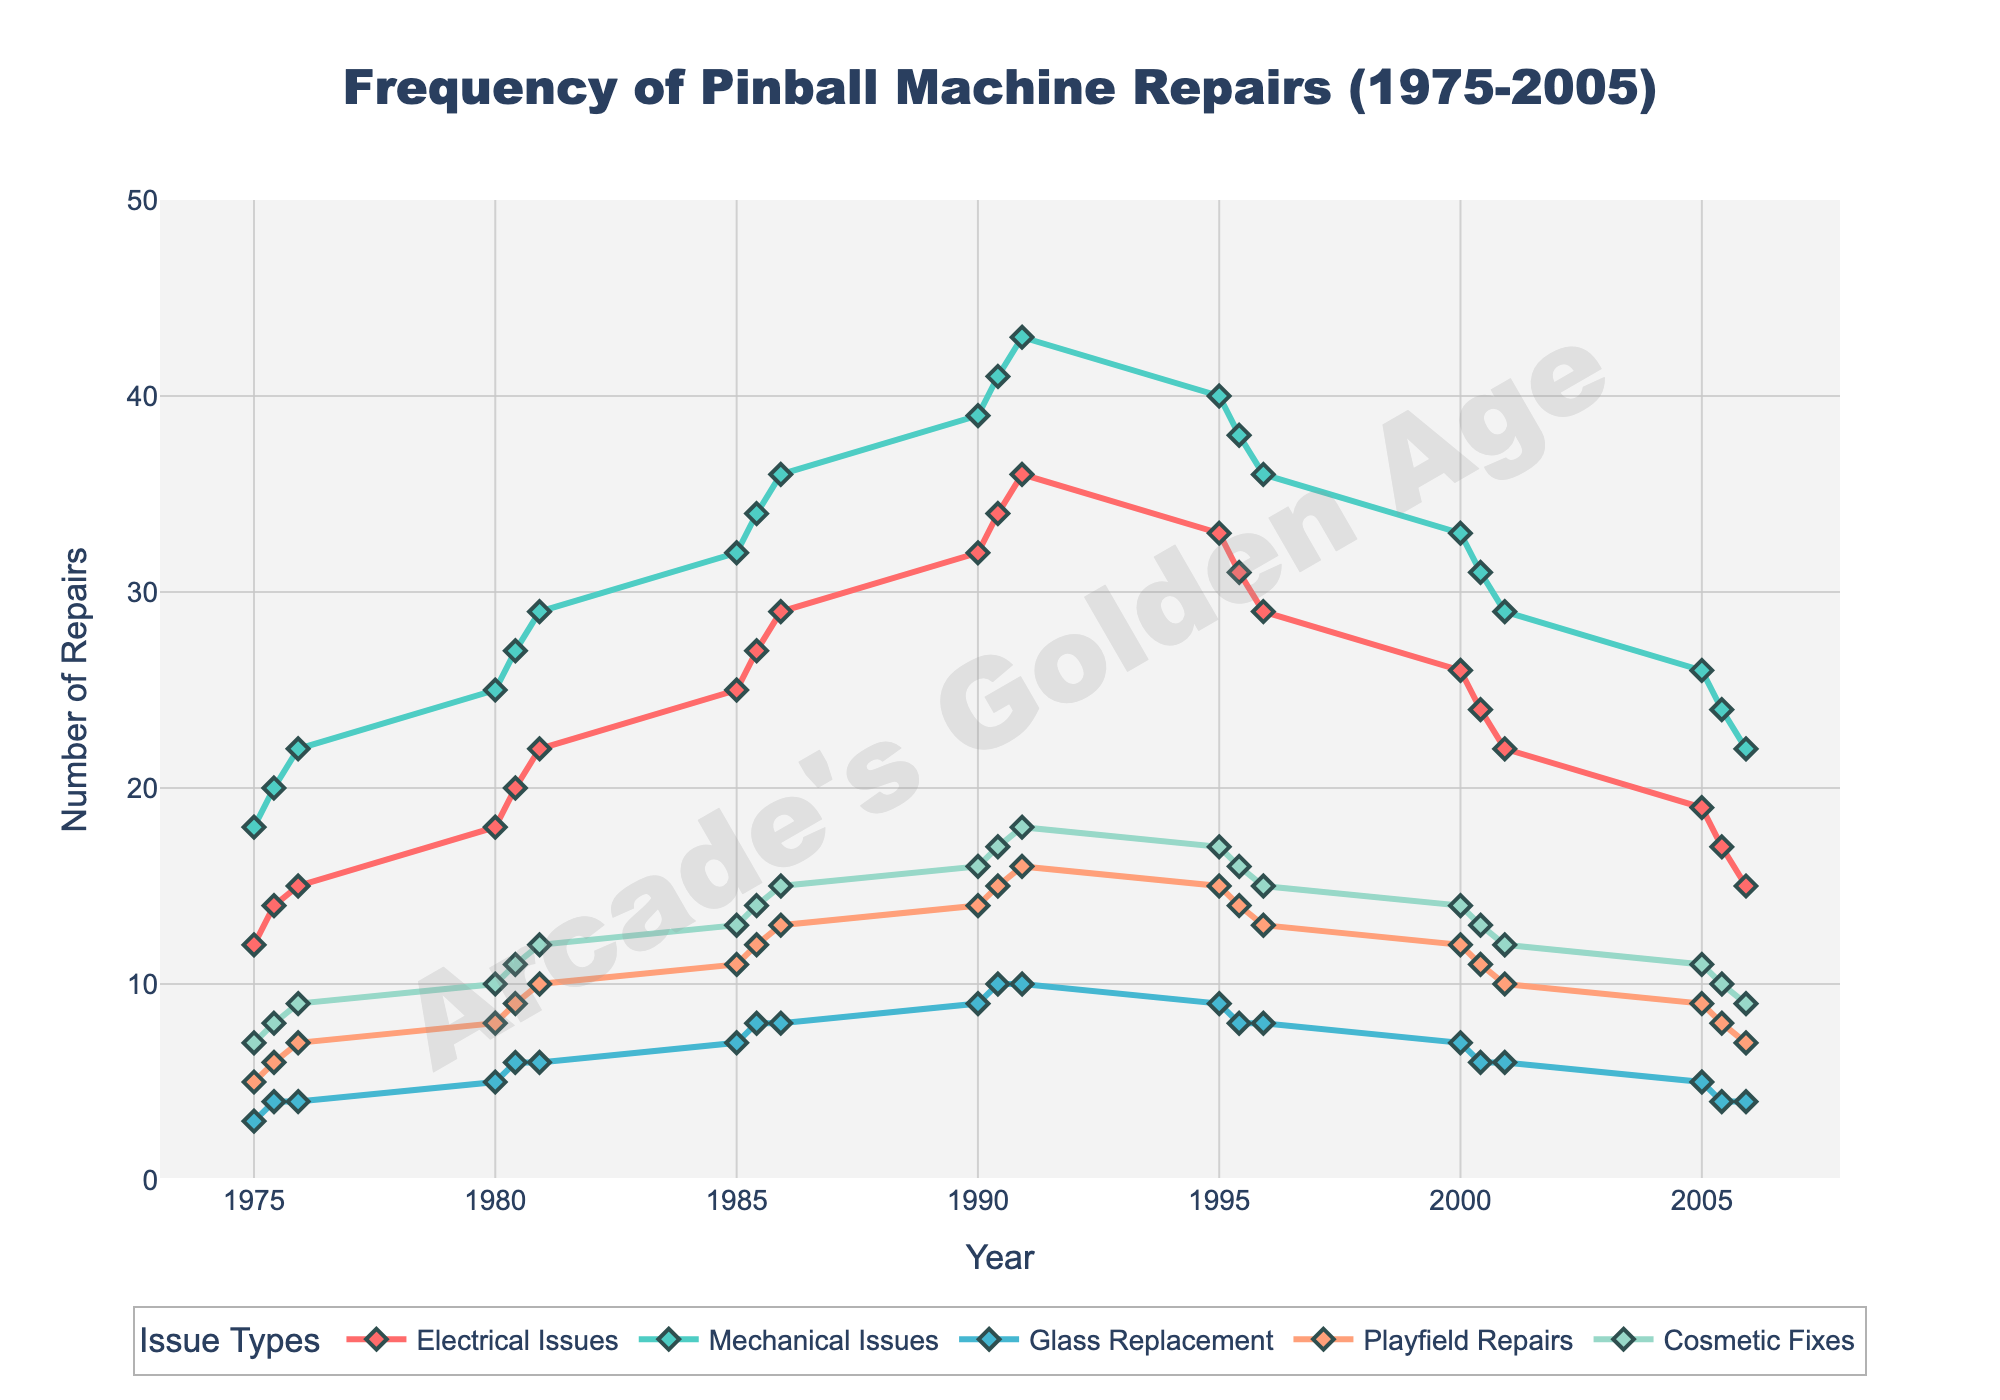What month and year had the highest number of mechanical issues? Look for the peak point in the Mechanical Issues line. The highest point is in June 1990 with 41 issues.
Answer: June 1990 What is the general trend for electrical issues from 1975 to 2005? Observe the Electrical Issues line from the start to end. The number rises from 12 in January 1975 to a peak of 36 in December 1990 and then falls to 15 by December 2005.
Answer: Increasing then decreasing Between 1980 and 1985, which issue type saw the greatest rise in frequency? Compare the difference in frequencies for each issue type between these years. Electrical Issues rose from 18 to 25 (+7). Mechanical Issues rose from 25 to 32 (+7). Glass Replacement rose from 5 to 7 (+2). Playfield Repairs rose from 8 to 11 (+3). Cosmetic Fixes rose from 10 to 13 (+3). The greatest rises are in Electrical and Mechanical Issues.
Answer: Electrical Issues & Mechanical Issues How did the frequency of playfield repairs change from 1985 to 1995? Look at the data points for Playfield Repairs in these years. It increased from 11 to a peak of 16 by December 1990, but then declined to 15 in January 1995 and finally 13 in December 1995.
Answer: Peaked and then decreased Which year had the least number of cosmetic fixes, and how many were there? Find the lowest point in the Cosmetic Fixes line. The lowest point is in January 1975 and December 2005, each with 9 issues.
Answer: January 1975 and December 2005, 9 issues Compare the frequency of electrical and mechanical issues in December 2000. Which one is higher, and what are their values? Check the data for December 2000 for both lines. Electrical Issues are at 22, while Mechanical Issues are at 29, so Mechanical Issues are higher.
Answer: Mechanical Issues, 29 vs 22 What year and month show a noticeable drop in glass replacement frequency, and what are the values before and after the drop? Observe the Glass Replacement line for sudden drops. A noticeable drop happens from 10 in December 1990 to 9 in January 1995.
Answer: December 1990 (10) to January 1995 (9) Which issue type generally shows the most stability over the recorded years? Compare the fluctuations in lines for each issue type through the chart. Glass Replacement shows minor fluctuations compared to others, generally between 3 and 10.
Answer: Glass Replacement What is the overall trend in mechanical issues from 1990 to 2005? Observe the Mechanical Issues line from 1990 to 2005. The trend is generally downward, starting from a peak of 43 in December 1990 and reducing to 22 by December 2005.
Answer: Downward Summarize the change in frequency for cosmetic fixes from 1975 to 2005. Track the Cosmetic Fixes line from the start to the end. It starts at 7 in January 1975, rises to a peak of 18 by December 1990, and drops back to 9 by December 2005.
Answer: Increased then decreased 